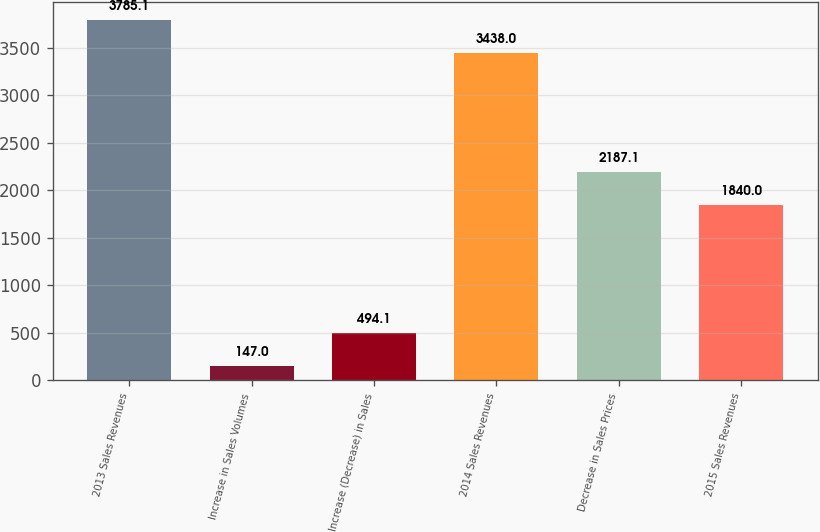Convert chart to OTSL. <chart><loc_0><loc_0><loc_500><loc_500><bar_chart><fcel>2013 Sales Revenues<fcel>Increase in Sales Volumes<fcel>Increase (Decrease) in Sales<fcel>2014 Sales Revenues<fcel>Decrease in Sales Prices<fcel>2015 Sales Revenues<nl><fcel>3785.1<fcel>147<fcel>494.1<fcel>3438<fcel>2187.1<fcel>1840<nl></chart> 